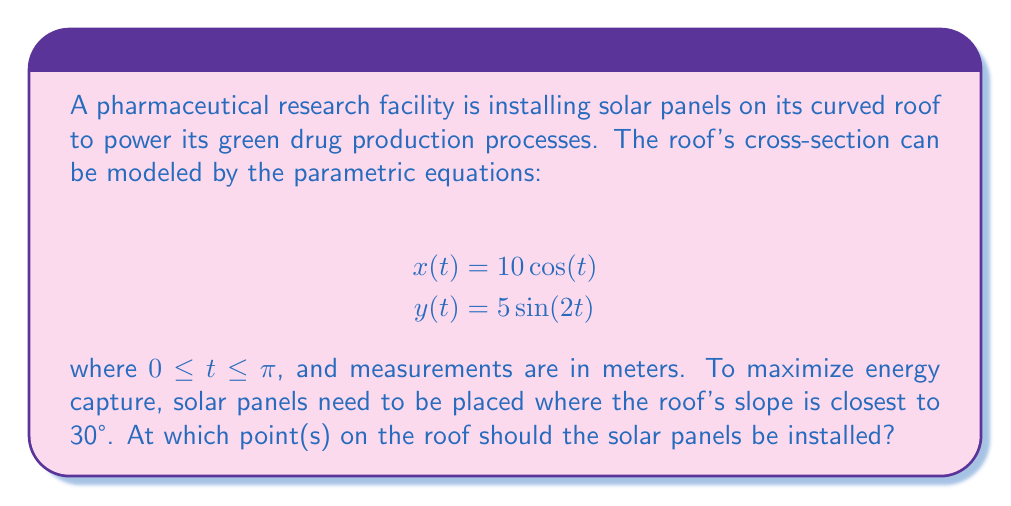Can you solve this math problem? To solve this problem, we need to follow these steps:

1) Calculate the slope of the roof at any point using the parametric equations.
2) Find the value(s) of t where the slope is equal to 30°.
3) Calculate the corresponding (x,y) coordinates for these t values.

Step 1: Calculating the slope

The slope at any point is given by $\frac{dy/dt}{dx/dt}$. Let's calculate these derivatives:

$$\frac{dx}{dt} = -10\sin(t)$$
$$\frac{dy}{dt} = 10\cos(2t)$$

Therefore, the slope is:

$$\text{slope} = \tan(\theta) = \frac{dy/dt}{dx/dt} = \frac{10\cos(2t)}{-10\sin(t)} = -\frac{\cos(2t)}{\sin(t)}$$

Step 2: Finding t where slope equals 30°

We want to find t where:

$$-\frac{\cos(2t)}{\sin(t)} = \tan(30°) = \frac{1}{\sqrt{3}}$$

Rearranging:

$$\cos(2t) = -\frac{\sin(t)}{\sqrt{3}}$$

Using the double angle formula $\cos(2t) = 1 - 2\sin^2(t)$, we get:

$$1 - 2\sin^2(t) = -\frac{\sin(t)}{\sqrt{3}}$$

This is a cubic equation in $\sin(t)$. Solving it numerically (as an exact solution is complex), we get:

$$t \approx 0.5236 \text{ or } 2.6180$$

Step 3: Calculating (x,y) coordinates

For $t \approx 0.5236$:
$$x \approx 10\cos(0.5236) \approx 8.66 \text{ m}$$
$$y \approx 5\sin(2 * 0.5236) \approx 4.33 \text{ m}$$

For $t \approx 2.6180$:
$$x \approx 10\cos(2.6180) \approx -8.66 \text{ m}$$
$$y \approx 5\sin(2 * 2.6180) \approx -4.33 \text{ m}$$
Answer: The solar panels should be installed at two points on the roof: approximately (8.66 m, 4.33 m) and (-8.66 m, -4.33 m). 